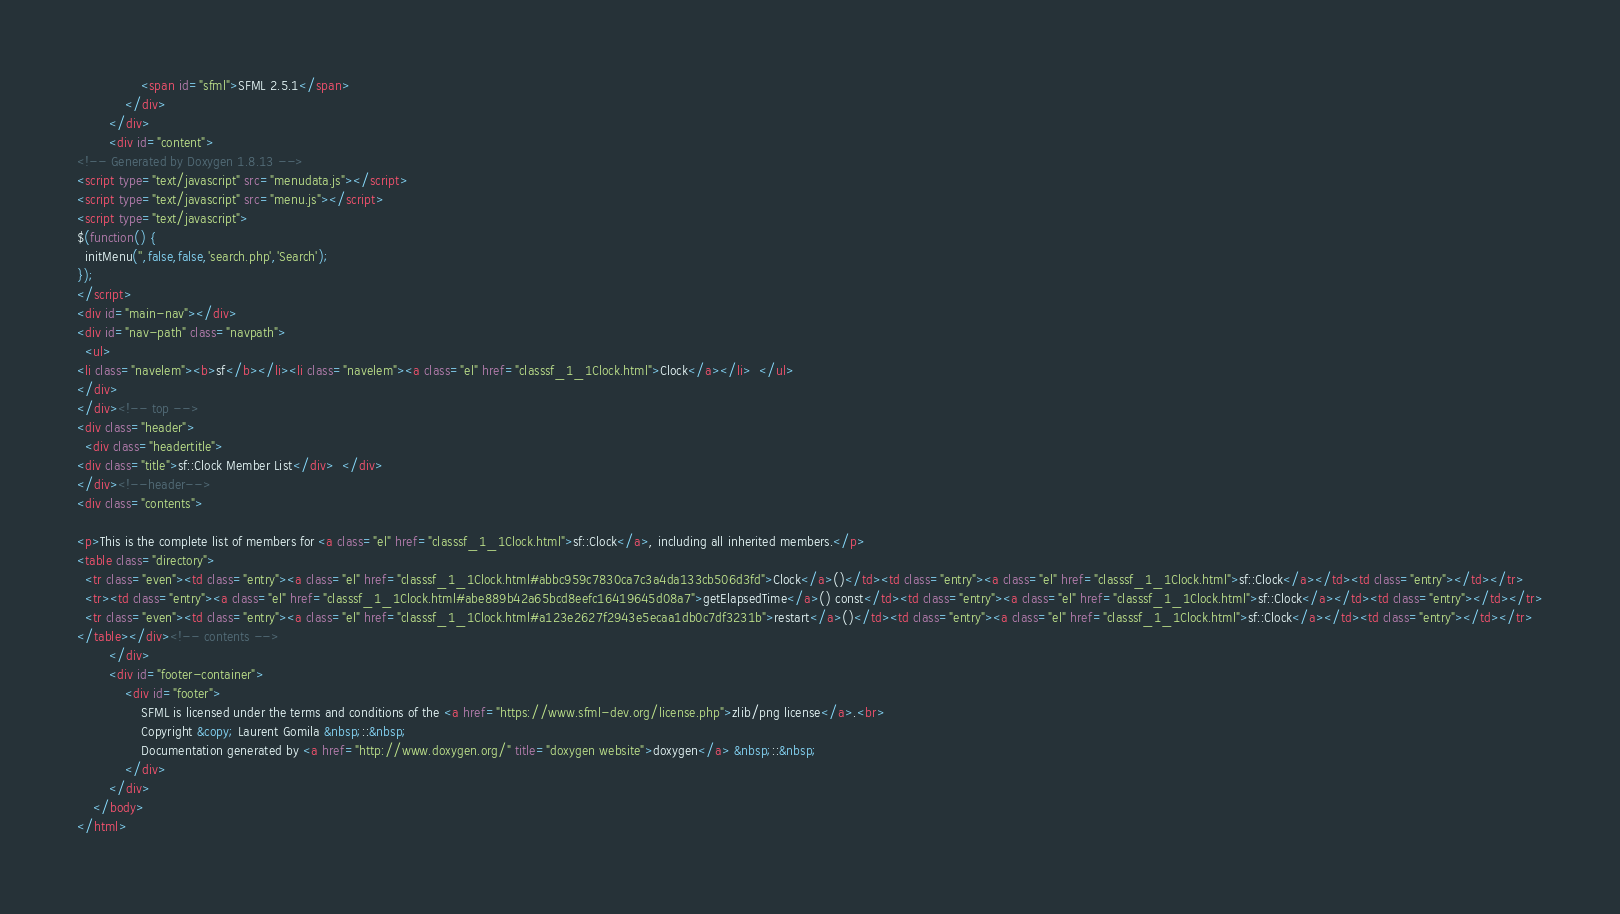<code> <loc_0><loc_0><loc_500><loc_500><_HTML_>                <span id="sfml">SFML 2.5.1</span>
            </div>
        </div>
        <div id="content">
<!-- Generated by Doxygen 1.8.13 -->
<script type="text/javascript" src="menudata.js"></script>
<script type="text/javascript" src="menu.js"></script>
<script type="text/javascript">
$(function() {
  initMenu('',false,false,'search.php','Search');
});
</script>
<div id="main-nav"></div>
<div id="nav-path" class="navpath">
  <ul>
<li class="navelem"><b>sf</b></li><li class="navelem"><a class="el" href="classsf_1_1Clock.html">Clock</a></li>  </ul>
</div>
</div><!-- top -->
<div class="header">
  <div class="headertitle">
<div class="title">sf::Clock Member List</div>  </div>
</div><!--header-->
<div class="contents">

<p>This is the complete list of members for <a class="el" href="classsf_1_1Clock.html">sf::Clock</a>, including all inherited members.</p>
<table class="directory">
  <tr class="even"><td class="entry"><a class="el" href="classsf_1_1Clock.html#abbc959c7830ca7c3a4da133cb506d3fd">Clock</a>()</td><td class="entry"><a class="el" href="classsf_1_1Clock.html">sf::Clock</a></td><td class="entry"></td></tr>
  <tr><td class="entry"><a class="el" href="classsf_1_1Clock.html#abe889b42a65bcd8eefc16419645d08a7">getElapsedTime</a>() const</td><td class="entry"><a class="el" href="classsf_1_1Clock.html">sf::Clock</a></td><td class="entry"></td></tr>
  <tr class="even"><td class="entry"><a class="el" href="classsf_1_1Clock.html#a123e2627f2943e5ecaa1db0c7df3231b">restart</a>()</td><td class="entry"><a class="el" href="classsf_1_1Clock.html">sf::Clock</a></td><td class="entry"></td></tr>
</table></div><!-- contents -->
        </div>
        <div id="footer-container">
            <div id="footer">
                SFML is licensed under the terms and conditions of the <a href="https://www.sfml-dev.org/license.php">zlib/png license</a>.<br>
                Copyright &copy; Laurent Gomila &nbsp;::&nbsp;
                Documentation generated by <a href="http://www.doxygen.org/" title="doxygen website">doxygen</a> &nbsp;::&nbsp;
            </div>
        </div>
    </body>
</html>
</code> 